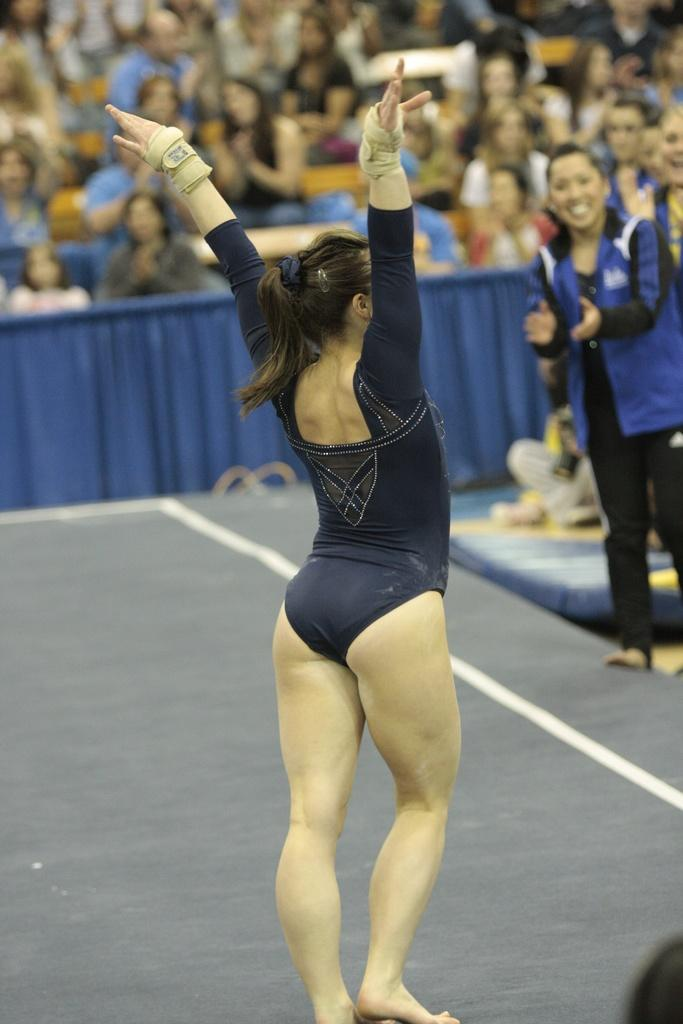What is the main subject in the foreground of the image? There is a woman standing in the foreground of the image. What can be seen in the background of the image? There is a group of people, a curtain, and other objects in the background of the image. What is visible at the bottom of the image? The floor is visible at the bottom of the image. What type of rhythm can be heard coming from the woman in the image? There is no indication of any sound or rhythm in the image, as it is a still photograph. 